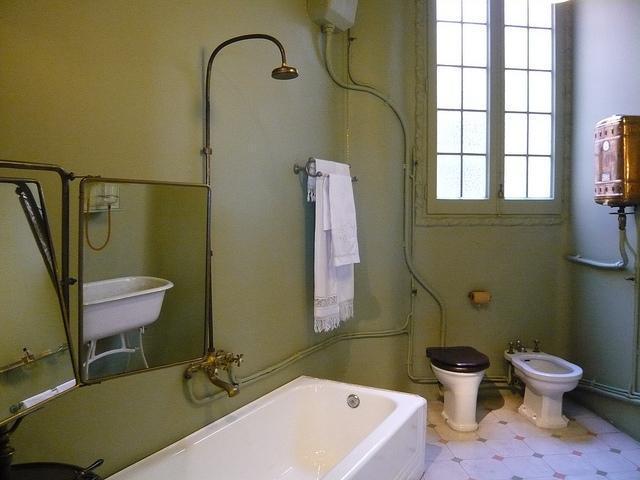How many toilets are in the picture?
Give a very brief answer. 2. How many sinks are there?
Give a very brief answer. 1. How many chairs are shown around the table?
Give a very brief answer. 0. 